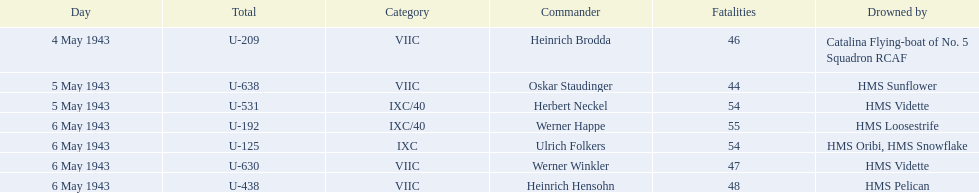Which were the names of the sinkers of the convoys? Catalina Flying-boat of No. 5 Squadron RCAF, HMS Sunflower, HMS Vidette, HMS Loosestrife, HMS Oribi, HMS Snowflake, HMS Vidette, HMS Pelican. What captain was sunk by the hms pelican? Heinrich Hensohn. 